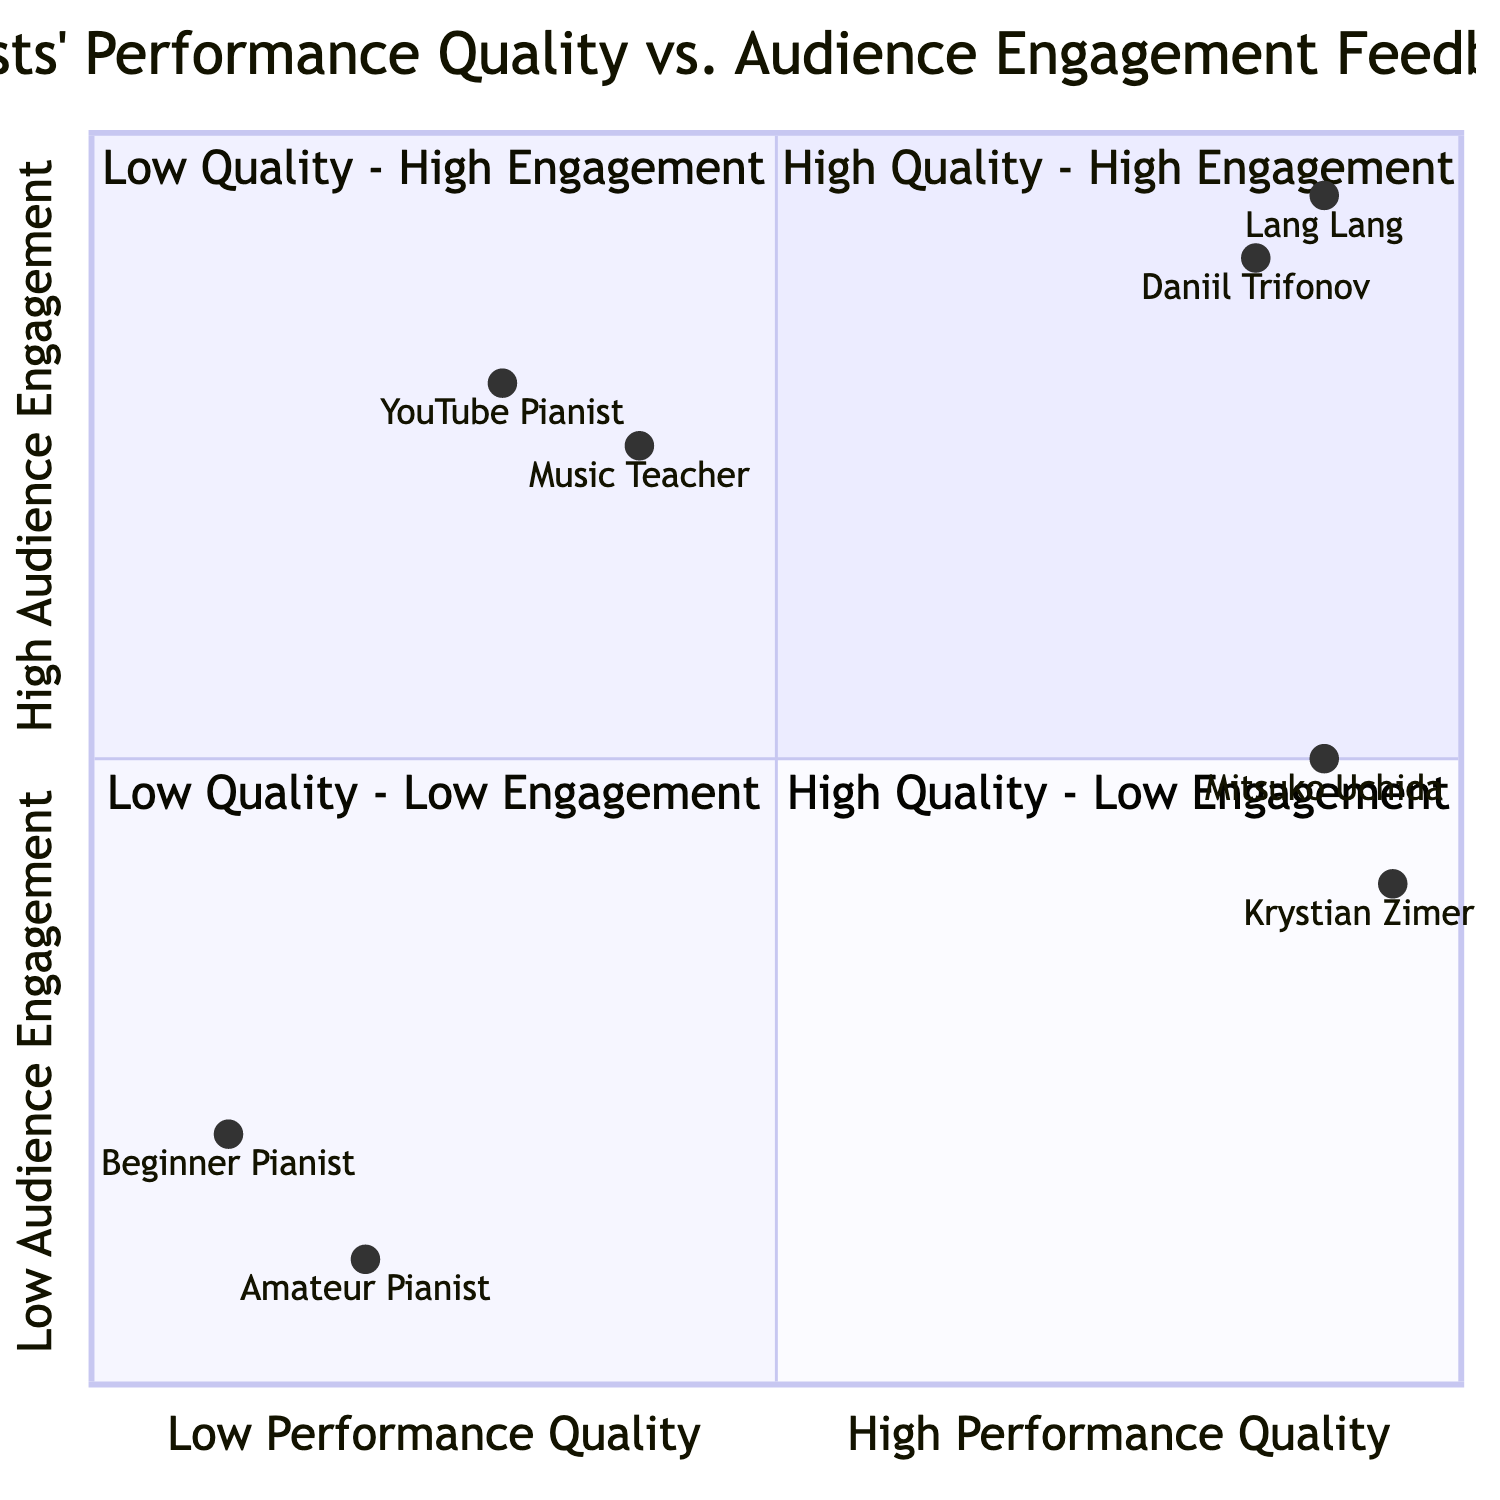What artist performed in the "High Quality - High Engagement" quadrant? The "High Quality - High Engagement" quadrant includes the artists Lang Lang and Daniil Trifonov. Either of these artists could be the answer.
Answer: Lang Lang or Daniil Trifonov How many artists are in the "Low Quality - Low Engagement" quadrant? This quadrant shows two artists: a Local Beginner Pianist and an Unfamiliar Amateur Pianist. Thus, the total number of artists is two.
Answer: 2 What type of engagement did Krystian Zimerman receive? In the "High Quality - Low Engagement" quadrant, Krystian Zimerman received "Critical Acclaim, Low Social Media Activity" as the type of audience engagement.
Answer: Critical Acclaim, Low Social Media Activity Which artist had the highest performance quality in the "Low Quality - High Engagement" quadrant? Among the artists in the "Low Quality - High Engagement" quadrant, the A Controversial YouTube Pianist has the higher performance quality compared to the Influential Music Teacher. Since the question specifically asks for high engagement, the answer remains consistent.
Answer: A Controversial YouTube Pianist What is the engagement type for the artist in the "High Quality - Low Engagement" quadrant performing "Chopin Piano Sonata No. 2"? This artist, Krystian Zimerman, received "Critical Acclaim, Low Social Media Activity" according to the data provided in the quadrant.
Answer: Critical Acclaim, Low Social Media Activity Which quadrant contains artists with both high-quality performances and low audience engagement? The quadrant that contains both high-quality performances and low audience engagement is the "High Quality - Low Engagement" quadrant, featuring two notable artists.
Answer: High Quality - Low Engagement What was the audience feedback for the performance "Pop Covers on Piano"? The performance "Pop Covers on Piano" by a Controversial YouTube Pianist received "Viral Social Media Response, Mixed Audience Reviews" as its audience feedback.
Answer: Viral Social Media Response, Mixed Audience Reviews Which two artists are positioned in the same quadrant, and what is that quadrant's name? The "High Quality - High Engagement" quadrant contains Lang Lang and Daniil Trifonov as the two artists positioned together in this quadrant.
Answer: High Quality - High Engagement 